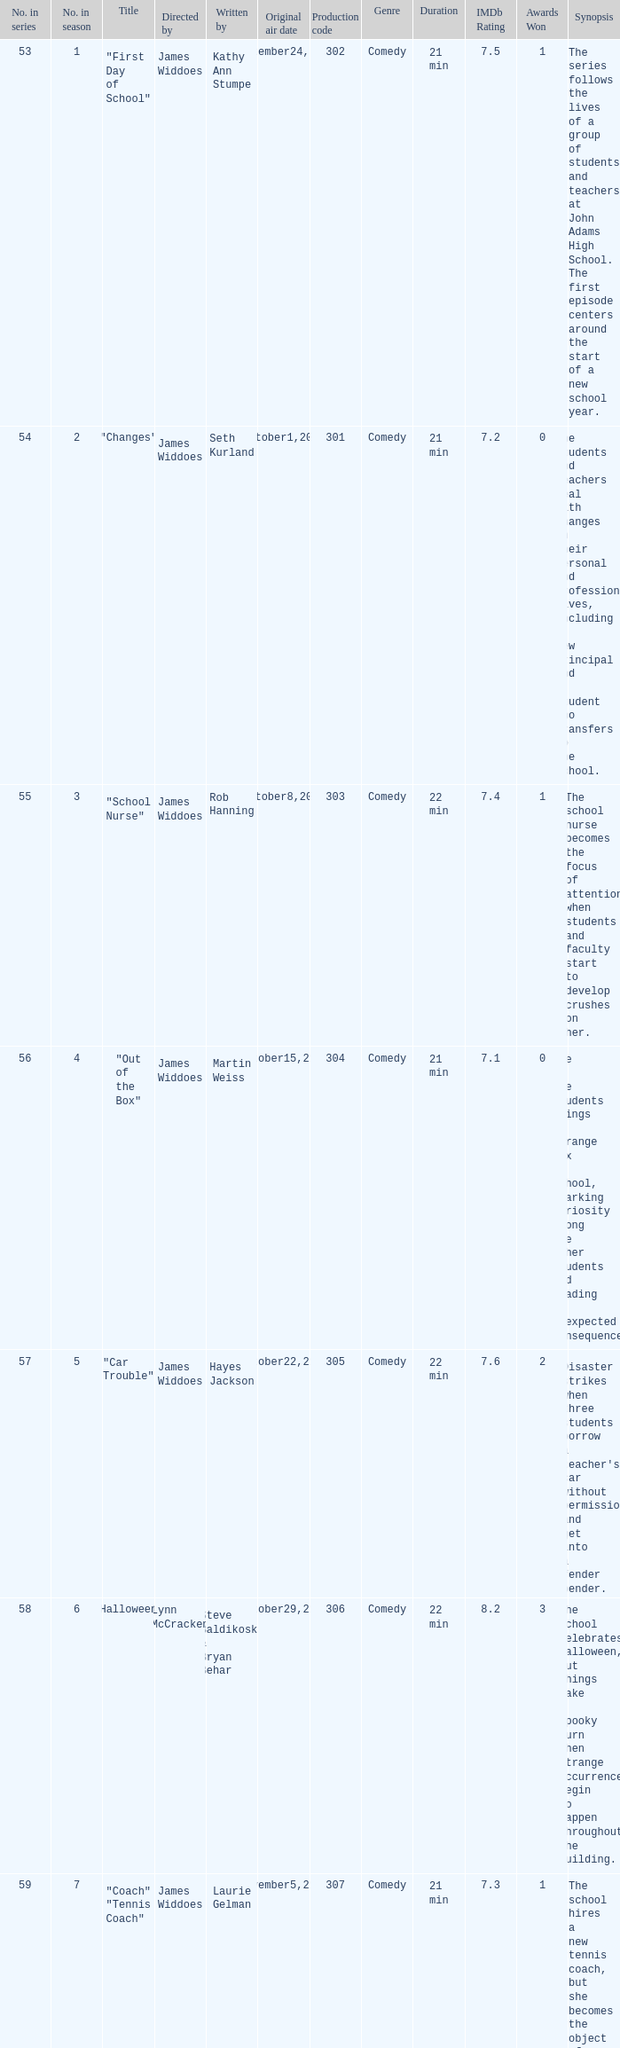Who directed "Freaky Friday"? James Widdoes. 